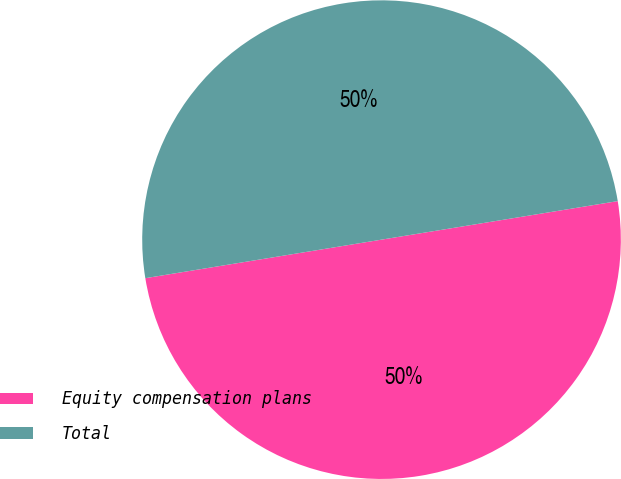<chart> <loc_0><loc_0><loc_500><loc_500><pie_chart><fcel>Equity compensation plans<fcel>Total<nl><fcel>50.0%<fcel>50.0%<nl></chart> 